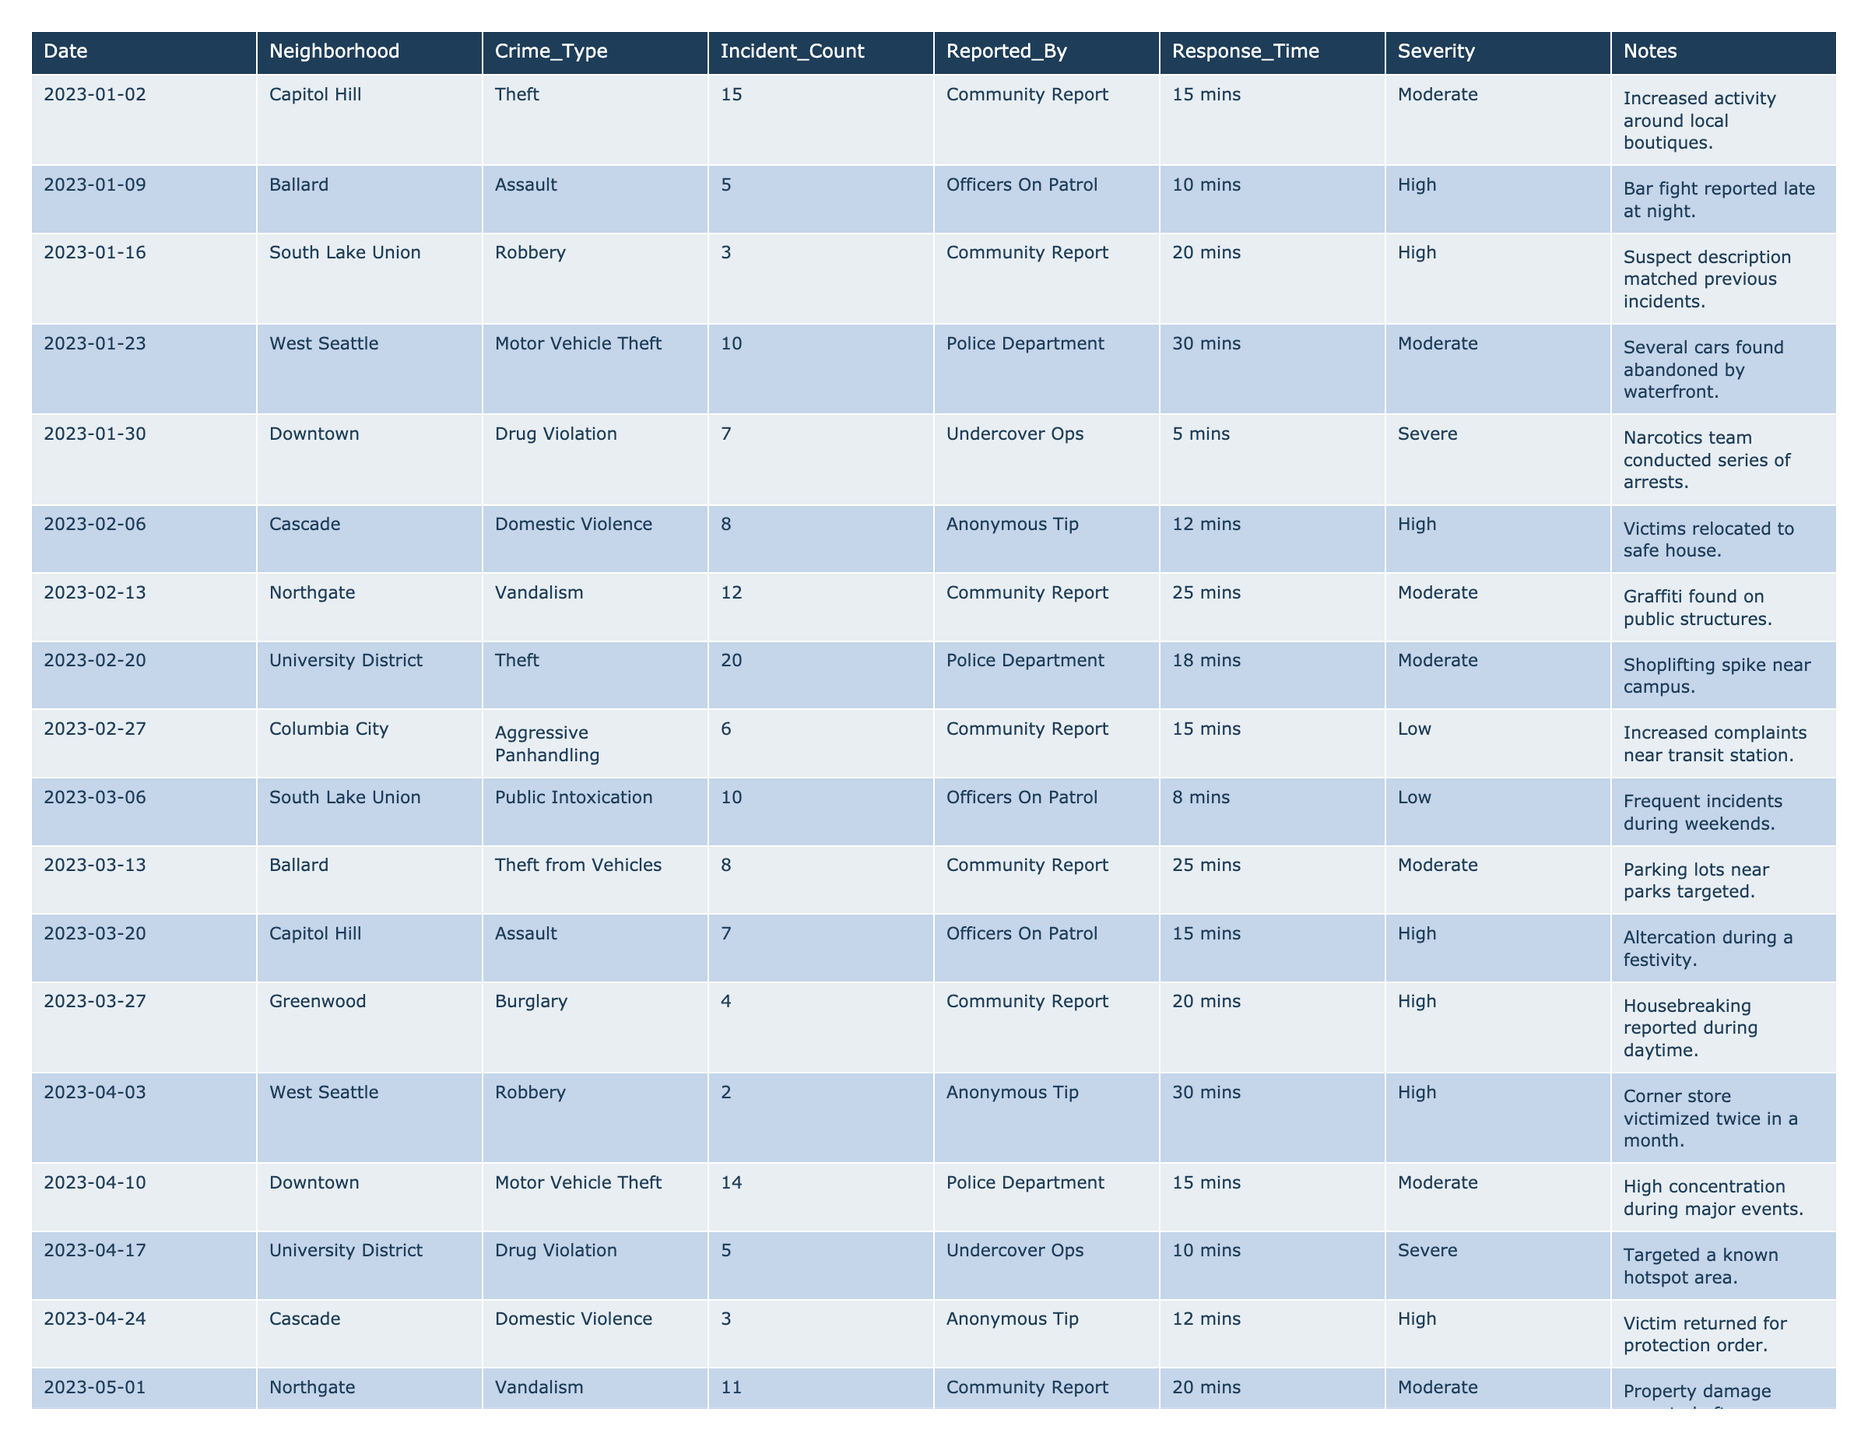What is the total number of theft incidents reported in Capitol Hill during January 2023? The table shows that on January 2nd, there were 15 theft incidents in Capitol Hill. There is only one entry for Capitol Hill in January, so the total is simply 15.
Answer: 15 How many assault incidents were reported in Ballard in 2023? The table has entries for Ballard on January 9th (5 assaults) and May 15th (6 assaults). Adding these gives 5 + 6 = 11 assault incidents in total.
Answer: 11 What was the most common crime type reported in the University District during 2023? There are two entries for the University District: theft (20 incidents on February 20) and drug violations (5 incidents on April 17). Since theft has a higher incident count, it is the most common crime type.
Answer: Theft How many total incidents of drug violations were reported across all neighborhoods in June 2023? In June, drug violations occurred on June 19th in Downtown, totaling 8 incidents. This is the only entry for drug violations in June, so the total for the month is 8 incidents.
Answer: 8 What percentage of total incidents reported in February 2023 were related to vandalism? In February, the total incidents are: 12 (Northgate vandalism) + 20 (University District theft) + 6 (Columbia City aggressive panhandling) + 8 (Cascade domestic violence) + 5 (University District drug violations) + 10 (South Lake Union public intoxication) = 61 incidents. Vandalism incidents in February: 12 (Northgate) + 0 (others). Thus, the percentage is (12 / 61) * 100 = approximately 19.67%.
Answer: 19.67% Which neighborhood experienced the highest number of total incidents reported during the first quarter of 2023? In the first quarter, the table shows totals: Capitol Hill (22), Ballard (13), South Lake Union (21), West Seattle (12), Downtown (7), Cascade (8), Northgate (12), Columbia City (6), and Greenwood (4). Capitol Hill reported the highest with 22 total incidents.
Answer: Capitol Hill Was there an increase or decrease in the number of drug violation incidents from January to April 2023? The table shows 7 drug violations in Downtown on January 30 and 5 in University District on April 17. This indicates a decrease, calculated as 7 - 5 = 2.
Answer: Decrease How many neighborhoods reported incidents of aggressive panhandling in 2023, and how many total incidents were noted? The table lists aggressive panhandling reports only for Columbia City in February (6 incidents) and again in May (5 incidents). Therefore, there are 2 neighborhoods (Columbia City) with a total of 6 + 5 = 11 incidents.
Answer: 1 neighborhood, 11 incidents What was the average response time for all incidents reported in South Lake Union throughout 2023? This includes incidents from January (20 mins), March (8 mins), and May (10 mins). The total response time is 20 + 8 + 10 = 38 minutes. There are 3 incidents, so the average response time is 38 / 3 = approximately 12.67 minutes.
Answer: 12.67 minutes Which crime type had the highest severity reported, and in which neighborhood did this occur? The table shows that drug violations were marked with "Severe" severity in both Downtown (January, April) and South Lake Union (March), so drug violations represent the highest severity.
Answer: Drug violations, Downtown/South Lake Union Was there any occurrence of domestic violence in the first quarter of 2023? The table indicates there were 8 incidents of domestic violence on February 6 in Cascade, confirming that such incidents did occur in the first quarter.
Answer: Yes 